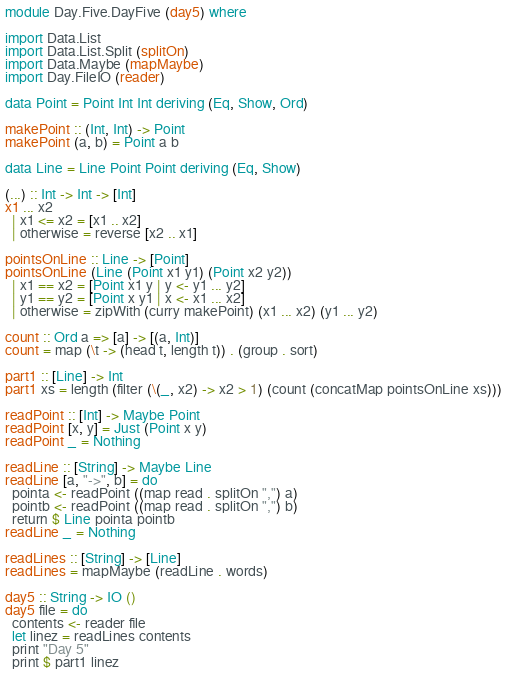<code> <loc_0><loc_0><loc_500><loc_500><_Haskell_>module Day.Five.DayFive (day5) where

import Data.List
import Data.List.Split (splitOn)
import Data.Maybe (mapMaybe)
import Day.FileIO (reader)

data Point = Point Int Int deriving (Eq, Show, Ord)

makePoint :: (Int, Int) -> Point
makePoint (a, b) = Point a b

data Line = Line Point Point deriving (Eq, Show)

(...) :: Int -> Int -> [Int]
x1 ... x2
  | x1 <= x2 = [x1 .. x2]
  | otherwise = reverse [x2 .. x1]

pointsOnLine :: Line -> [Point]
pointsOnLine (Line (Point x1 y1) (Point x2 y2))
  | x1 == x2 = [Point x1 y | y <- y1 ... y2]
  | y1 == y2 = [Point x y1 | x <- x1 ... x2]
  | otherwise = zipWith (curry makePoint) (x1 ... x2) (y1 ... y2)

count :: Ord a => [a] -> [(a, Int)]
count = map (\t -> (head t, length t)) . (group . sort)

part1 :: [Line] -> Int
part1 xs = length (filter (\(_, x2) -> x2 > 1) (count (concatMap pointsOnLine xs)))

readPoint :: [Int] -> Maybe Point
readPoint [x, y] = Just (Point x y)
readPoint _ = Nothing

readLine :: [String] -> Maybe Line
readLine [a, "->", b] = do
  pointa <- readPoint ((map read . splitOn ",") a)
  pointb <- readPoint ((map read . splitOn ",") b)
  return $ Line pointa pointb
readLine _ = Nothing

readLines :: [String] -> [Line]
readLines = mapMaybe (readLine . words)

day5 :: String -> IO ()
day5 file = do
  contents <- reader file
  let linez = readLines contents
  print "Day 5"
  print $ part1 linez
</code> 